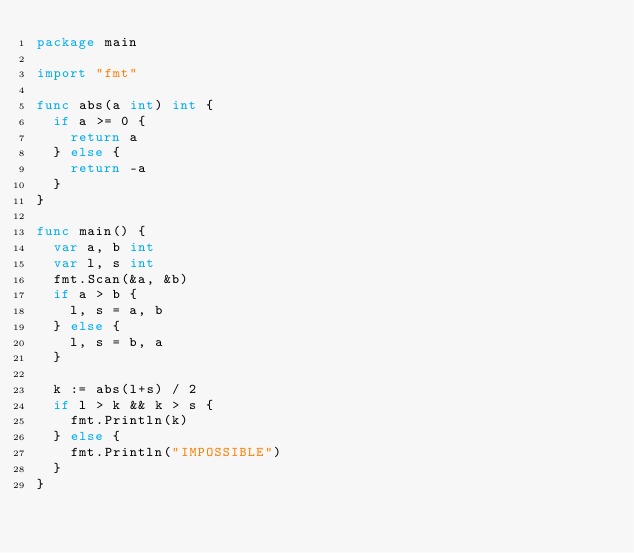Convert code to text. <code><loc_0><loc_0><loc_500><loc_500><_Go_>package main

import "fmt"

func abs(a int) int {
	if a >= 0 {
		return a
	} else {
		return -a
	}
}

func main() {
	var a, b int
	var l, s int
	fmt.Scan(&a, &b)
	if a > b {
		l, s = a, b
	} else {
		l, s = b, a
	}

	k := abs(l+s) / 2
	if l > k && k > s {
		fmt.Println(k)
	} else {
		fmt.Println("IMPOSSIBLE")
	}
}</code> 